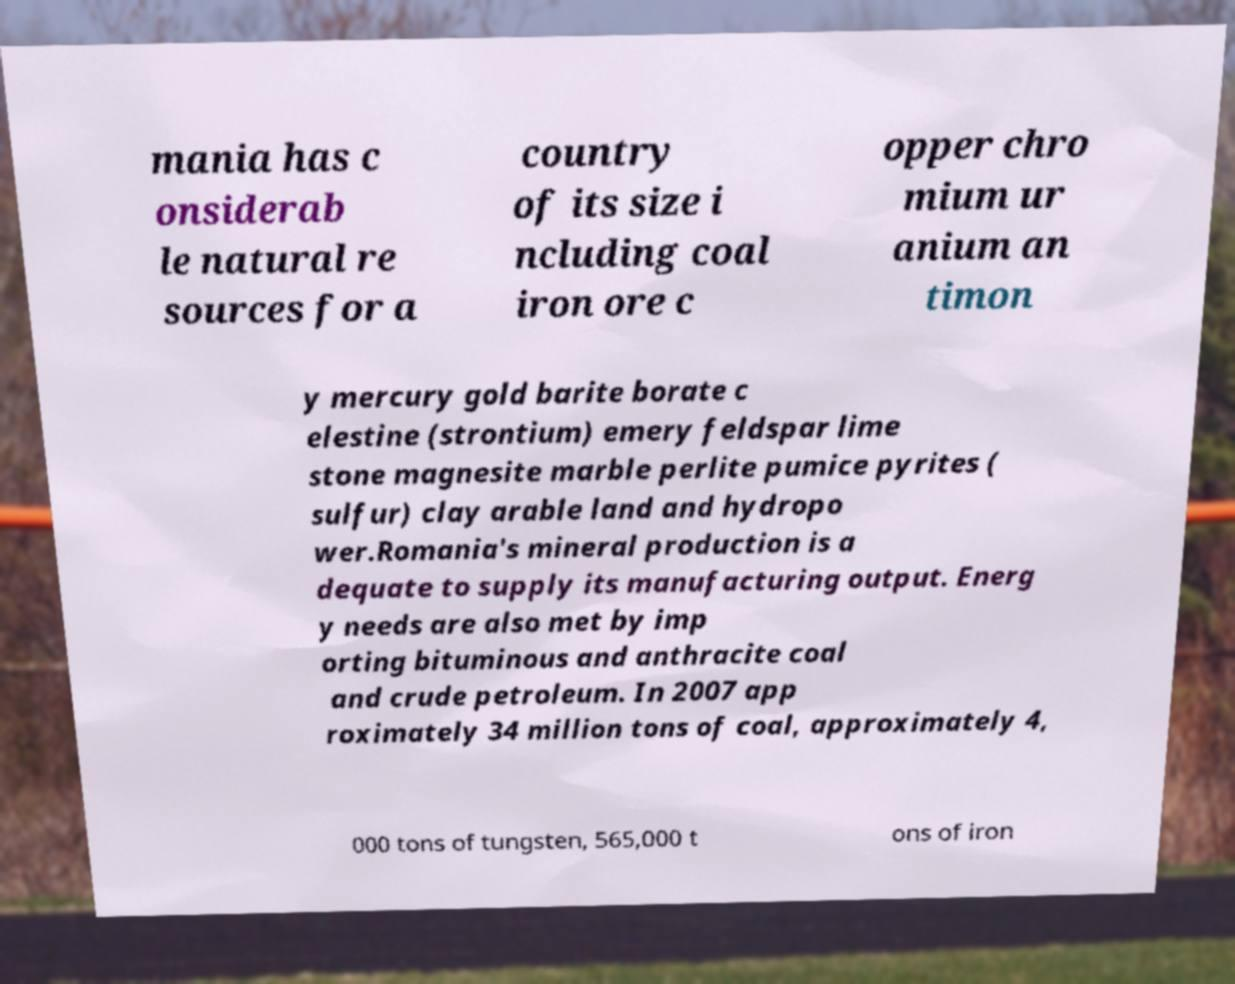Please identify and transcribe the text found in this image. mania has c onsiderab le natural re sources for a country of its size i ncluding coal iron ore c opper chro mium ur anium an timon y mercury gold barite borate c elestine (strontium) emery feldspar lime stone magnesite marble perlite pumice pyrites ( sulfur) clay arable land and hydropo wer.Romania's mineral production is a dequate to supply its manufacturing output. Energ y needs are also met by imp orting bituminous and anthracite coal and crude petroleum. In 2007 app roximately 34 million tons of coal, approximately 4, 000 tons of tungsten, 565,000 t ons of iron 